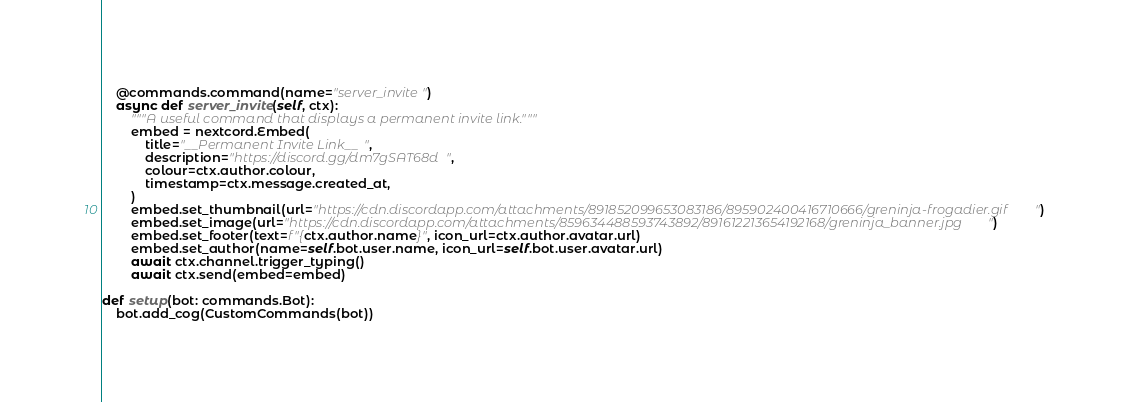Convert code to text. <code><loc_0><loc_0><loc_500><loc_500><_Python_>
	@commands.command(name="server_invite") 
	async def server_invite(self, ctx):
		"""A useful command that displays a permanent invite link."""
		embed = nextcord.Embed(
			title="__Permanent Invite Link__",
			description="https://discord.gg/dm7gSAT68d",
			colour=ctx.author.colour,
			timestamp=ctx.message.created_at,
		)
		embed.set_thumbnail(url="https://cdn.discordapp.com/attachments/891852099653083186/895902400416710666/greninja-frogadier.gif")
		embed.set_image(url="https://cdn.discordapp.com/attachments/859634488593743892/891612213654192168/greninja_banner.jpg")
		embed.set_footer(text=f"{ctx.author.name}", icon_url=ctx.author.avatar.url)
		embed.set_author(name=self.bot.user.name, icon_url=self.bot.user.avatar.url)
		await ctx.channel.trigger_typing()
		await ctx.send(embed=embed)

def setup(bot: commands.Bot):
	bot.add_cog(CustomCommands(bot))
</code> 